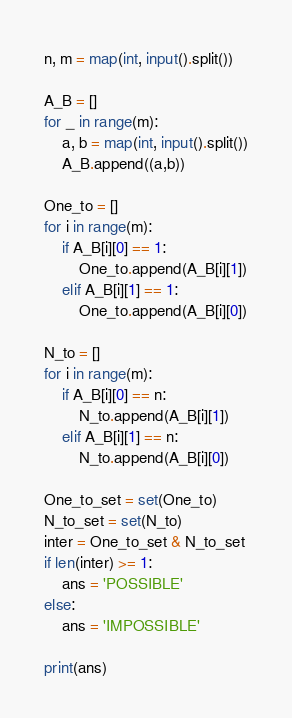<code> <loc_0><loc_0><loc_500><loc_500><_Python_>n, m = map(int, input().split())

A_B = []
for _ in range(m):
    a, b = map(int, input().split())
    A_B.append((a,b))

One_to = []
for i in range(m):
    if A_B[i][0] == 1:
        One_to.append(A_B[i][1])
    elif A_B[i][1] == 1:
        One_to.append(A_B[i][0])

N_to = []
for i in range(m):
    if A_B[i][0] == n:
        N_to.append(A_B[i][1])
    elif A_B[i][1] == n:
        N_to.append(A_B[i][0])

One_to_set = set(One_to)
N_to_set = set(N_to)
inter = One_to_set & N_to_set
if len(inter) >= 1:
    ans = 'POSSIBLE'
else:
    ans = 'IMPOSSIBLE'

print(ans)</code> 